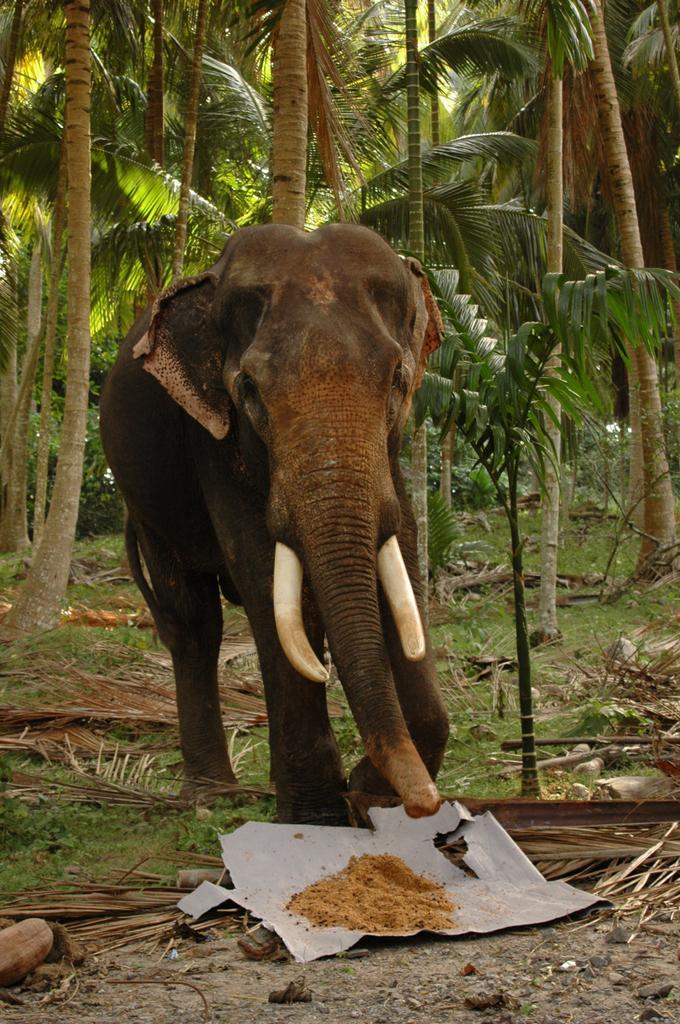Can you describe this image briefly? An elephant is walking on the ground and there are cut down branches,powder on a paper on the ground. In the background there are trees and plants. 